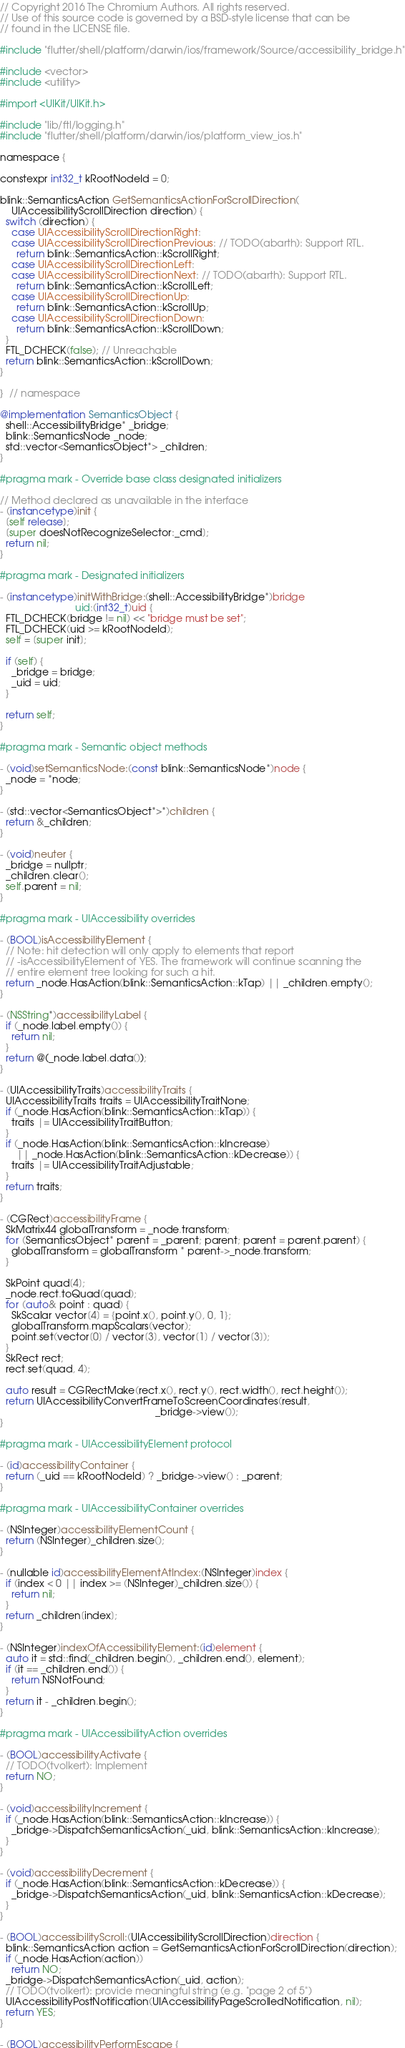Convert code to text. <code><loc_0><loc_0><loc_500><loc_500><_ObjectiveC_>// Copyright 2016 The Chromium Authors. All rights reserved.
// Use of this source code is governed by a BSD-style license that can be
// found in the LICENSE file.

#include "flutter/shell/platform/darwin/ios/framework/Source/accessibility_bridge.h"

#include <vector>
#include <utility>

#import <UIKit/UIKit.h>

#include "lib/ftl/logging.h"
#include "flutter/shell/platform/darwin/ios/platform_view_ios.h"

namespace {

constexpr int32_t kRootNodeId = 0;

blink::SemanticsAction GetSemanticsActionForScrollDirection(
    UIAccessibilityScrollDirection direction) {
  switch (direction) {
    case UIAccessibilityScrollDirectionRight:
    case UIAccessibilityScrollDirectionPrevious: // TODO(abarth): Support RTL.
      return blink::SemanticsAction::kScrollRight;
    case UIAccessibilityScrollDirectionLeft:
    case UIAccessibilityScrollDirectionNext: // TODO(abarth): Support RTL.
      return blink::SemanticsAction::kScrollLeft;
    case UIAccessibilityScrollDirectionUp:
      return blink::SemanticsAction::kScrollUp;
    case UIAccessibilityScrollDirectionDown:
      return blink::SemanticsAction::kScrollDown;
  }
  FTL_DCHECK(false); // Unreachable
  return blink::SemanticsAction::kScrollDown;
}

}  // namespace

@implementation SemanticsObject {
  shell::AccessibilityBridge* _bridge;
  blink::SemanticsNode _node;
  std::vector<SemanticsObject*> _children;
}

#pragma mark - Override base class designated initializers

// Method declared as unavailable in the interface
- (instancetype)init {
  [self release];
  [super doesNotRecognizeSelector:_cmd];
  return nil;
}

#pragma mark - Designated initializers

- (instancetype)initWithBridge:(shell::AccessibilityBridge*)bridge
                           uid:(int32_t)uid {
  FTL_DCHECK(bridge != nil) << "bridge must be set";
  FTL_DCHECK(uid >= kRootNodeId);
  self = [super init];

  if (self) {
    _bridge = bridge;
    _uid = uid;
  }

  return self;
}

#pragma mark - Semantic object methods

- (void)setSemanticsNode:(const blink::SemanticsNode*)node {
  _node = *node;
}

- (std::vector<SemanticsObject*>*)children {
  return &_children;
}

- (void)neuter {
  _bridge = nullptr;
  _children.clear();
  self.parent = nil;
}

#pragma mark - UIAccessibility overrides

- (BOOL)isAccessibilityElement {
  // Note: hit detection will only apply to elements that report
  // -isAccessibilityElement of YES. The framework will continue scanning the
  // entire element tree looking for such a hit.
  return _node.HasAction(blink::SemanticsAction::kTap) || _children.empty();
}

- (NSString*)accessibilityLabel {
  if (_node.label.empty()) {
    return nil;
  }
  return @(_node.label.data());
}

- (UIAccessibilityTraits)accessibilityTraits {
  UIAccessibilityTraits traits = UIAccessibilityTraitNone;
  if (_node.HasAction(blink::SemanticsAction::kTap)) {
    traits |= UIAccessibilityTraitButton;
  }
  if (_node.HasAction(blink::SemanticsAction::kIncrease)
      || _node.HasAction(blink::SemanticsAction::kDecrease)) {
    traits |= UIAccessibilityTraitAdjustable;
  }
  return traits;
}

- (CGRect)accessibilityFrame {
  SkMatrix44 globalTransform = _node.transform;
  for (SemanticsObject* parent = _parent; parent; parent = parent.parent) {
    globalTransform = globalTransform * parent->_node.transform;
  }

  SkPoint quad[4];
  _node.rect.toQuad(quad);
  for (auto& point : quad) {
    SkScalar vector[4] = {point.x(), point.y(), 0, 1};
    globalTransform.mapScalars(vector);
    point.set(vector[0] / vector[3], vector[1] / vector[3]);
  }
  SkRect rect;
  rect.set(quad, 4);

  auto result = CGRectMake(rect.x(), rect.y(), rect.width(), rect.height());
  return UIAccessibilityConvertFrameToScreenCoordinates(result,
                                                        _bridge->view());
}

#pragma mark - UIAccessibilityElement protocol

- (id)accessibilityContainer {
  return (_uid == kRootNodeId) ? _bridge->view() : _parent;
}

#pragma mark - UIAccessibilityContainer overrides

- (NSInteger)accessibilityElementCount {
  return (NSInteger)_children.size();
}

- (nullable id)accessibilityElementAtIndex:(NSInteger)index {
  if (index < 0 || index >= (NSInteger)_children.size()) {
    return nil;
  }
  return _children[index];
}

- (NSInteger)indexOfAccessibilityElement:(id)element {
  auto it = std::find(_children.begin(), _children.end(), element);
  if (it == _children.end()) {
    return NSNotFound;
  }
  return it - _children.begin();
}

#pragma mark - UIAccessibilityAction overrides

- (BOOL)accessibilityActivate {
  // TODO(tvolkert): Implement
  return NO;
}

- (void)accessibilityIncrement {
  if (_node.HasAction(blink::SemanticsAction::kIncrease)) {
    _bridge->DispatchSemanticsAction(_uid, blink::SemanticsAction::kIncrease);
  }
}

- (void)accessibilityDecrement {
  if (_node.HasAction(blink::SemanticsAction::kDecrease)) {
    _bridge->DispatchSemanticsAction(_uid, blink::SemanticsAction::kDecrease);
  }
}

- (BOOL)accessibilityScroll:(UIAccessibilityScrollDirection)direction {
  blink::SemanticsAction action = GetSemanticsActionForScrollDirection(direction);
  if (_node.HasAction(action))
    return NO;
  _bridge->DispatchSemanticsAction(_uid, action);
  // TODO(tvolkert): provide meaningful string (e.g. "page 2 of 5")
  UIAccessibilityPostNotification(UIAccessibilityPageScrolledNotification, nil);
  return YES;
}

- (BOOL)accessibilityPerformEscape {</code> 